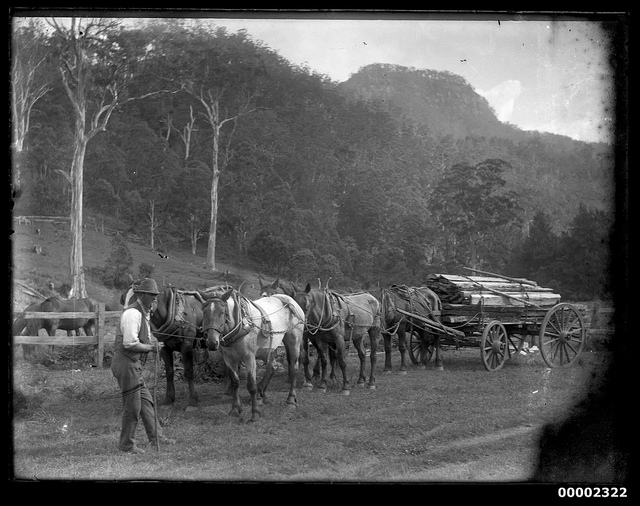How many wheels does the wagon have? The wagon in the image has four wheels. This type of wagon is typically used for transporting heavy loads and is drawn by a team of horses, as seen in the image. Each of the wagons is equipped with two pairs of wheels, providing the necessary support and stability for the cargo. 